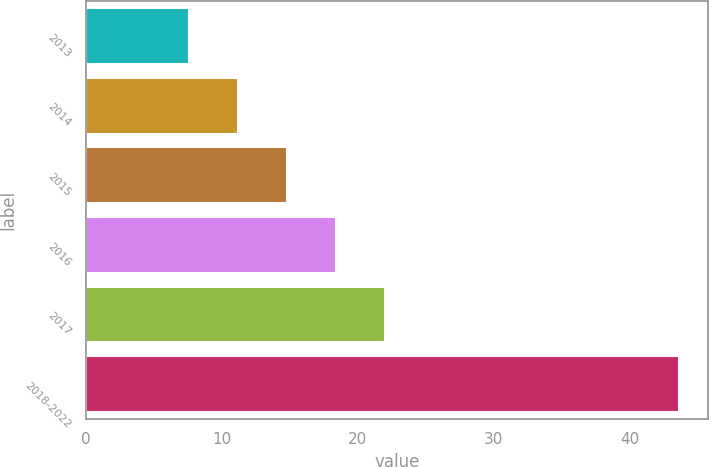Convert chart. <chart><loc_0><loc_0><loc_500><loc_500><bar_chart><fcel>2013<fcel>2014<fcel>2015<fcel>2016<fcel>2017<fcel>2018-2022<nl><fcel>7.6<fcel>11.2<fcel>14.8<fcel>18.4<fcel>22<fcel>43.6<nl></chart> 